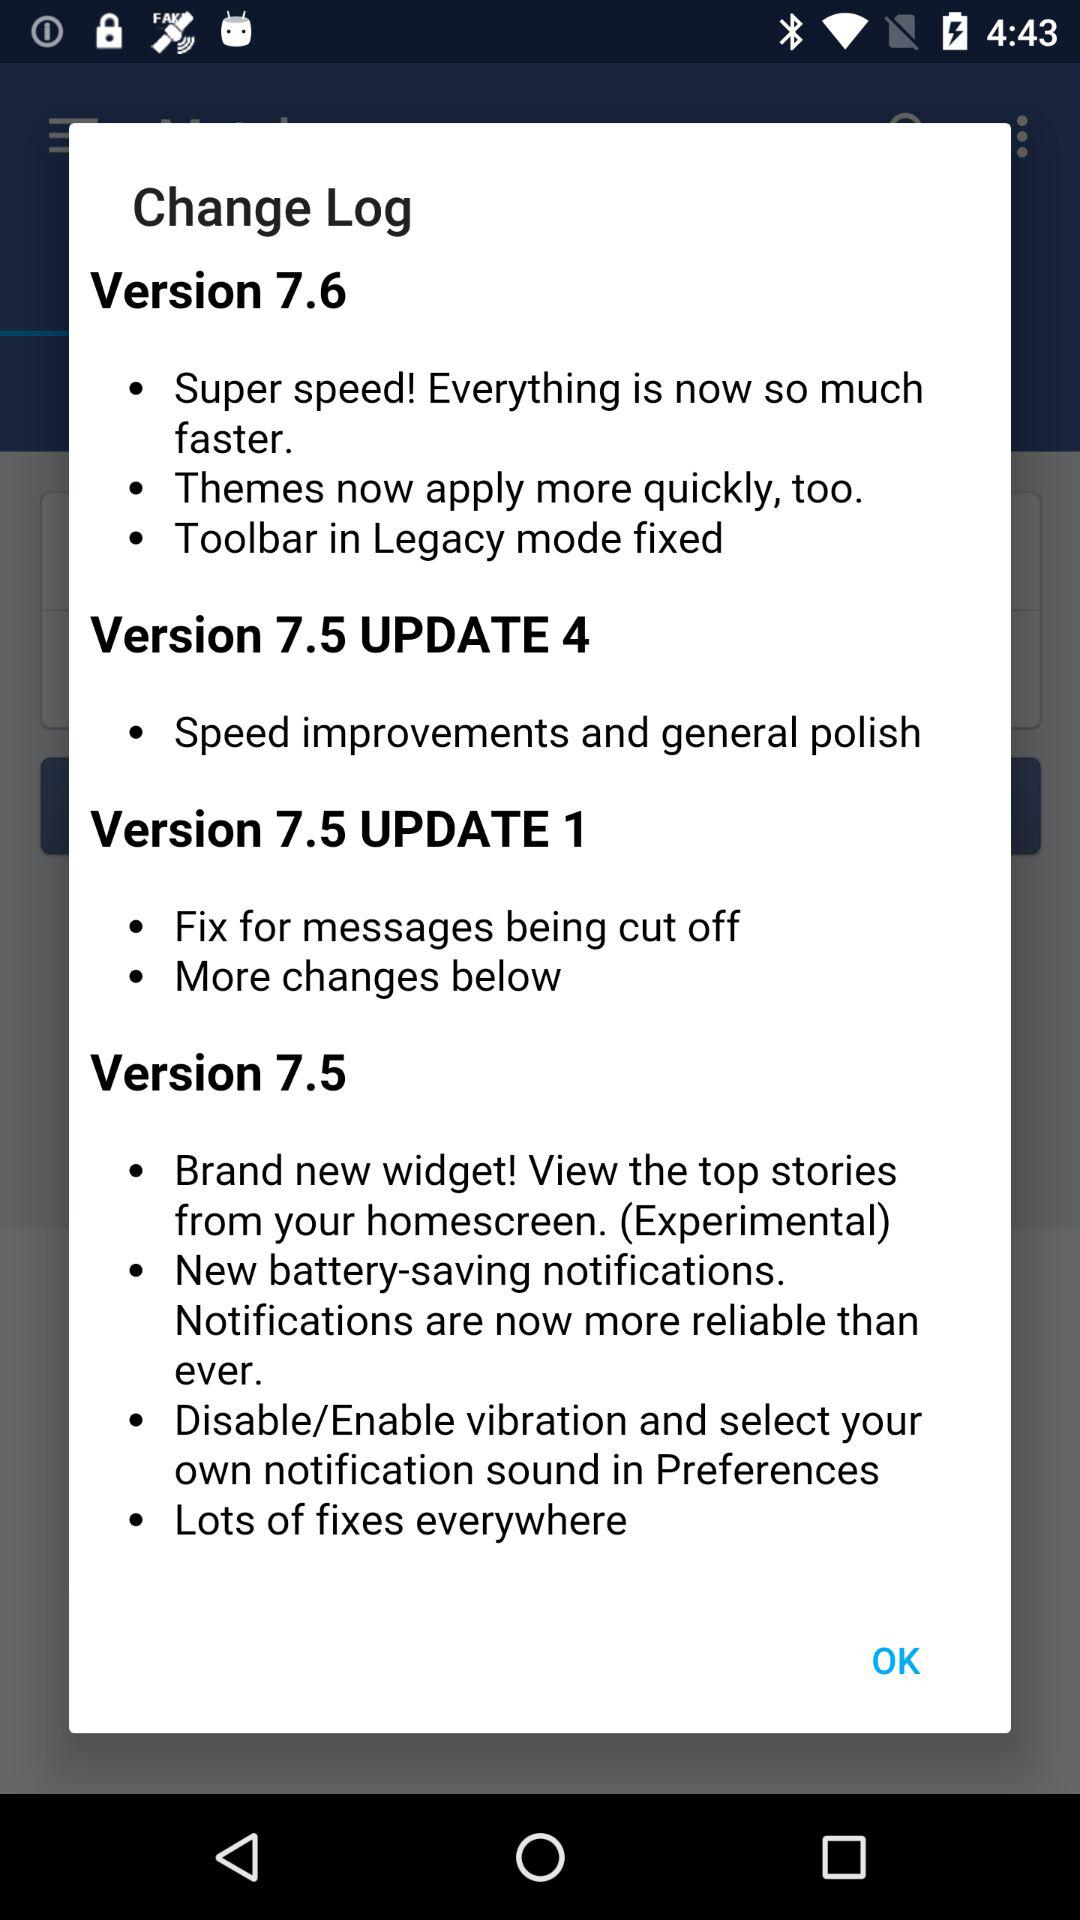What are the features of "Version 7.5 UPDATE 4"? The features are speed improvements and general polish. 